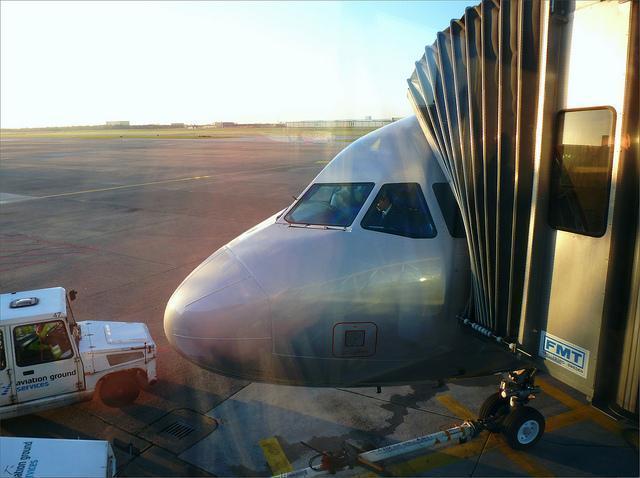What is this part of the plane known as?
Pick the correct solution from the four options below to address the question.
Options: Cockpit, stern, runway, first class. Cockpit. 